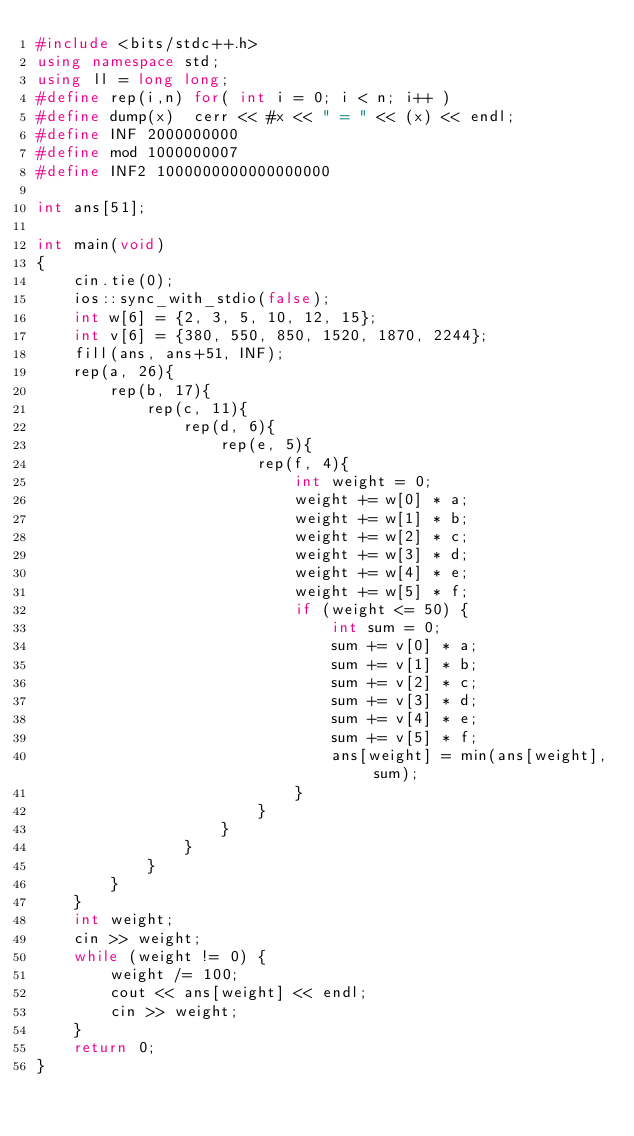<code> <loc_0><loc_0><loc_500><loc_500><_C++_>#include <bits/stdc++.h>
using namespace std;
using ll = long long;
#define rep(i,n) for( int i = 0; i < n; i++ )
#define dump(x)  cerr << #x << " = " << (x) << endl;
#define INF 2000000000
#define mod 1000000007
#define INF2 1000000000000000000

int ans[51];

int main(void)
{
    cin.tie(0);
    ios::sync_with_stdio(false);
    int w[6] = {2, 3, 5, 10, 12, 15};
    int v[6] = {380, 550, 850, 1520, 1870, 2244};
    fill(ans, ans+51, INF);
    rep(a, 26){
        rep(b, 17){
            rep(c, 11){
                rep(d, 6){
                    rep(e, 5){
                        rep(f, 4){
                            int weight = 0;
                            weight += w[0] * a;
                            weight += w[1] * b;
                            weight += w[2] * c;
                            weight += w[3] * d;
                            weight += w[4] * e;
                            weight += w[5] * f;
                            if (weight <= 50) {
                                int sum = 0;
                                sum += v[0] * a;
                                sum += v[1] * b;
                                sum += v[2] * c;
                                sum += v[3] * d;
                                sum += v[4] * e;
                                sum += v[5] * f;
                                ans[weight] = min(ans[weight], sum);
                            }
                        }
                    }
                }
            }
        }
    }
    int weight;
    cin >> weight;
    while (weight != 0) {
        weight /= 100;
        cout << ans[weight] << endl;
        cin >> weight;
    }
    return 0;
}</code> 